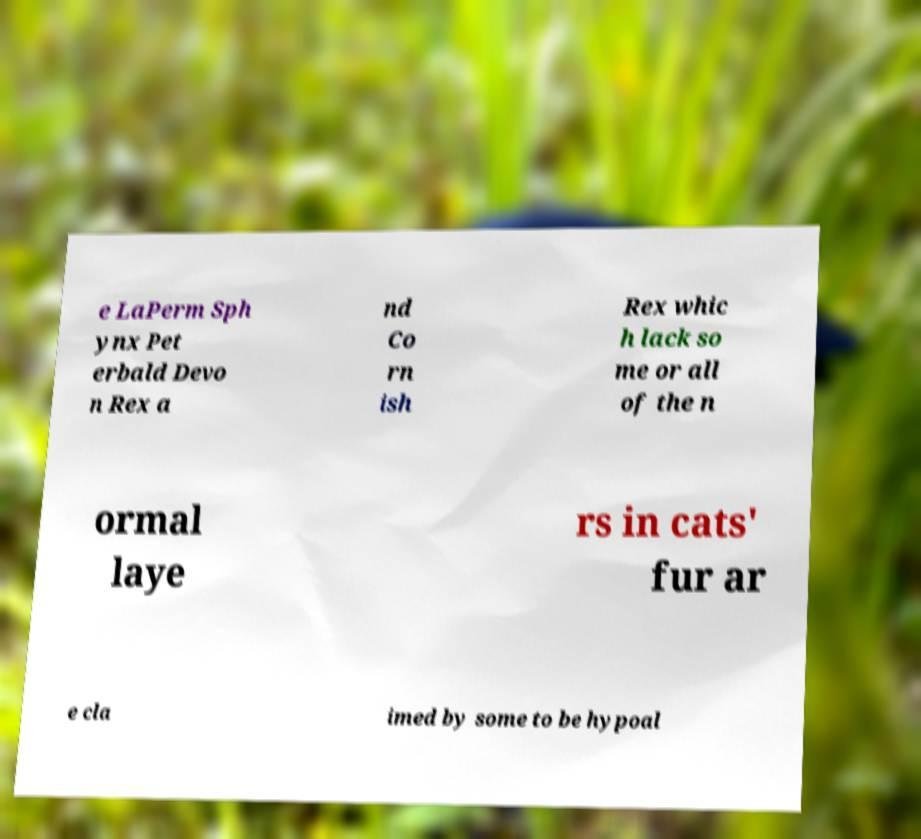For documentation purposes, I need the text within this image transcribed. Could you provide that? e LaPerm Sph ynx Pet erbald Devo n Rex a nd Co rn ish Rex whic h lack so me or all of the n ormal laye rs in cats' fur ar e cla imed by some to be hypoal 